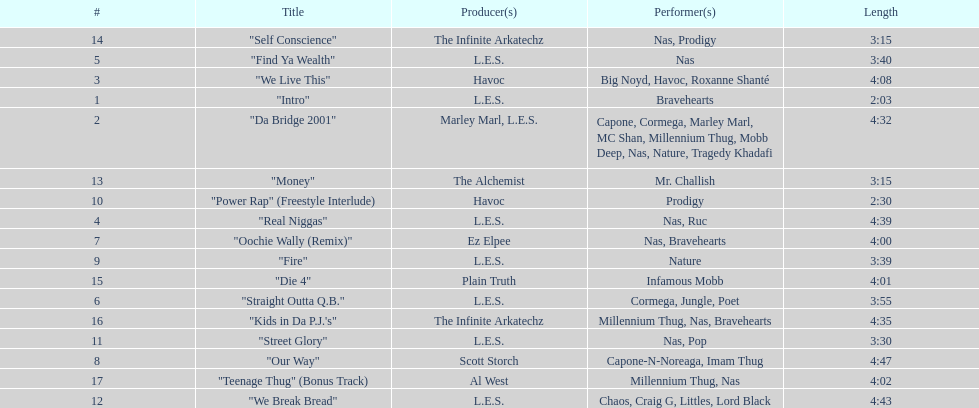What is the first song on the album produced by havoc? "We Live This". 